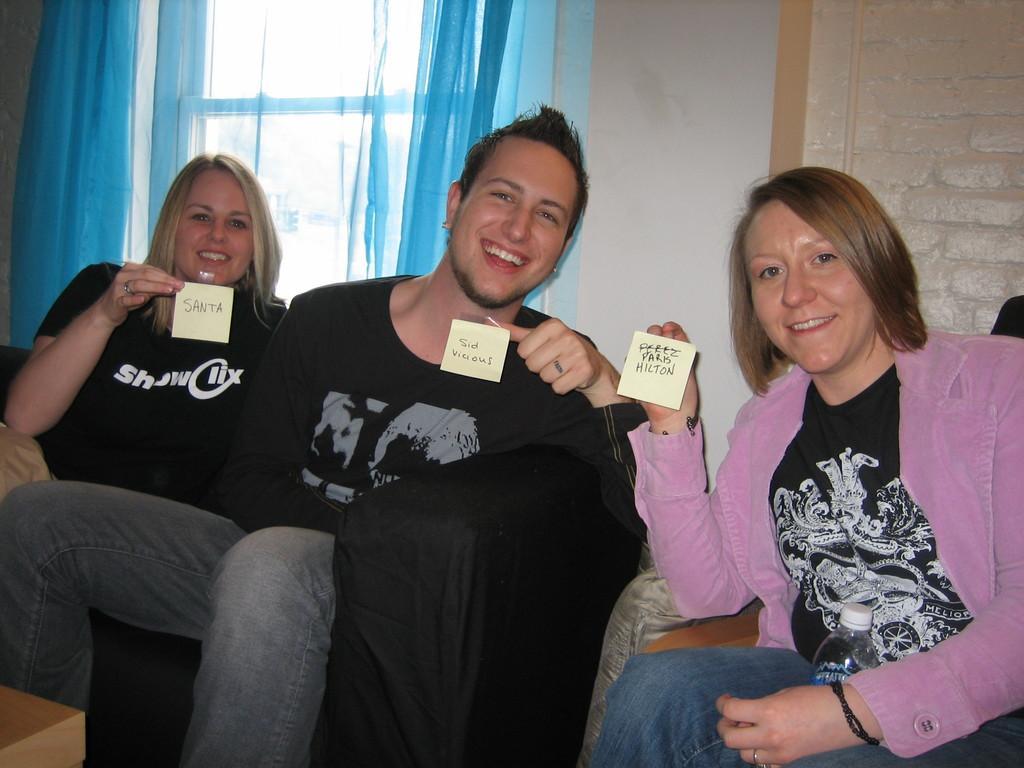In one or two sentences, can you explain what this image depicts? In this image, we can see some people sitting on the sofas, they are holding name tags, in the background, we can see a wall and a window, we can see the curtains. 